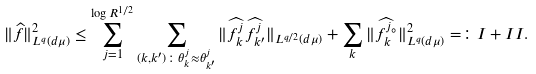Convert formula to latex. <formula><loc_0><loc_0><loc_500><loc_500>\| \widehat { f } \| _ { L ^ { q } ( d \mu ) } ^ { 2 } \leq \sum _ { j = 1 } ^ { \log R ^ { 1 / 2 } } \sum _ { ( k , k ^ { \prime } ) \colon \theta ^ { j } _ { k } \approx \theta ^ { j } _ { k ^ { \prime } } } \| \widehat { f _ { k } ^ { j } } \widehat { f _ { k ^ { \prime } } ^ { j } } \| _ { L ^ { q / 2 } ( d \mu ) } + \sum _ { k } \| \widehat { f _ { k } ^ { j _ { \circ } } } \| _ { L ^ { q } ( d \mu ) } ^ { 2 } = \colon I + I I .</formula> 